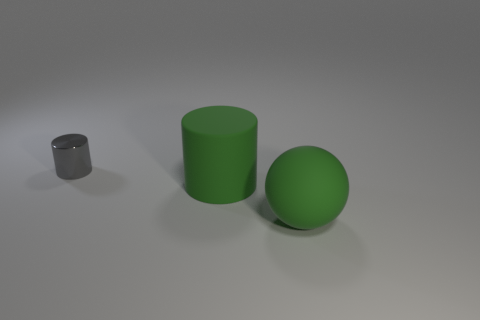Is the number of large brown objects greater than the number of gray metallic cylinders?
Offer a very short reply. No. There is a thing that is in front of the large cylinder; what is its color?
Provide a short and direct response. Green. How many other metal objects are the same size as the shiny object?
Offer a terse response. 0. There is a green object that is the same shape as the gray shiny object; what is it made of?
Provide a succinct answer. Rubber. There is a large rubber cylinder; what number of small things are right of it?
Your answer should be compact. 0. What is the shape of the green matte thing that is in front of the big thing on the left side of the big matte ball?
Your answer should be very brief. Sphere. There is a green thing that is the same material as the green sphere; what shape is it?
Your answer should be very brief. Cylinder. Do the rubber object behind the large green rubber ball and the rubber object that is in front of the big matte cylinder have the same size?
Your answer should be compact. Yes. There is a thing that is behind the green cylinder; what is its shape?
Offer a very short reply. Cylinder. What color is the matte cylinder?
Your answer should be very brief. Green. 